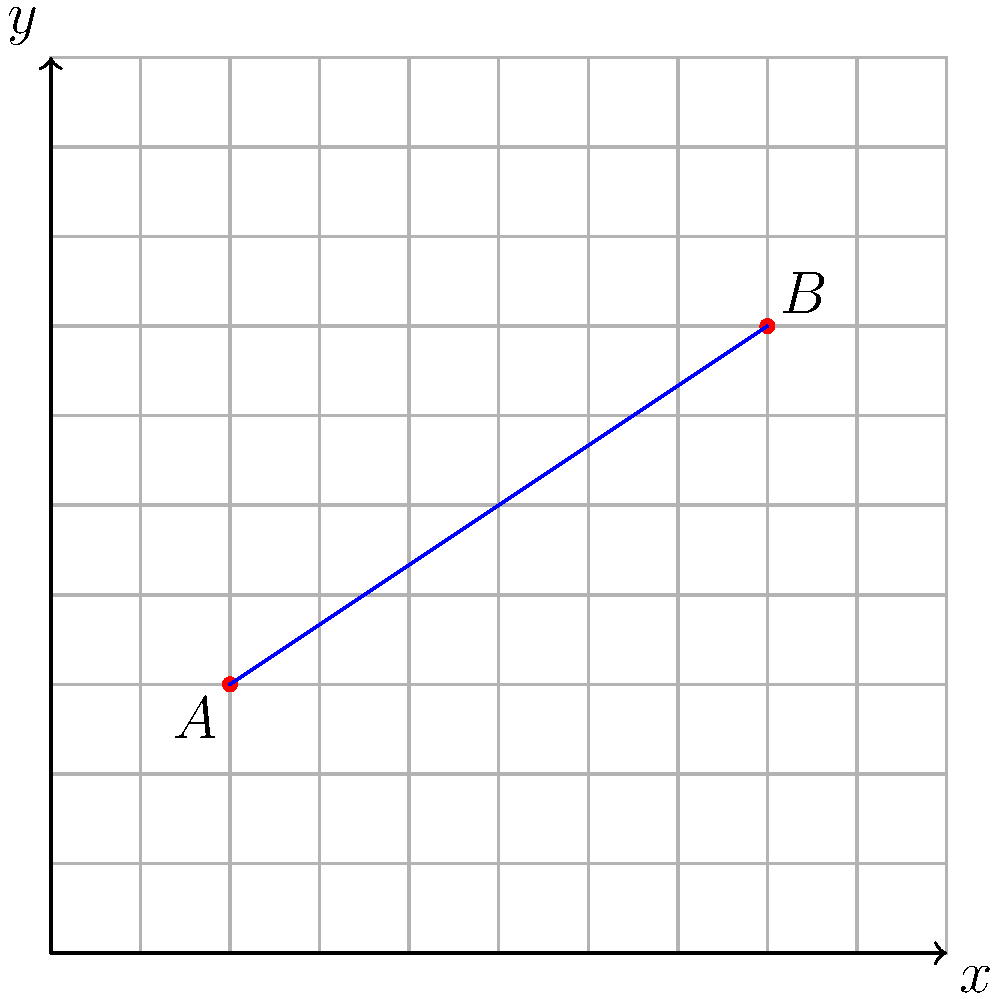St. Mary's Catholic School and St. Joseph's Catholic School are two important educational institutions for the Omosso community. On a coordinate grid, St. Mary's is located at point $A(2,3)$ and St. Joseph's is at point $B(8,7)$. The city plans to build a new shared facility at the midpoint of the line segment connecting these two schools. What are the coordinates of this new facility? To find the midpoint of a line segment, we can use the midpoint formula:

$$ \text{Midpoint} = \left(\frac{x_1 + x_2}{2}, \frac{y_1 + y_2}{2}\right) $$

Where $(x_1, y_1)$ are the coordinates of one endpoint and $(x_2, y_2)$ are the coordinates of the other endpoint.

Given:
- Point $A$ (St. Mary's): $(2, 3)$
- Point $B$ (St. Joseph's): $(8, 7)$

Let's calculate:

1) For the x-coordinate:
   $\frac{x_1 + x_2}{2} = \frac{2 + 8}{2} = \frac{10}{2} = 5$

2) For the y-coordinate:
   $\frac{y_1 + y_2}{2} = \frac{3 + 7}{2} = \frac{10}{2} = 5$

Therefore, the midpoint coordinates are $(5, 5)$.
Answer: $(5, 5)$ 